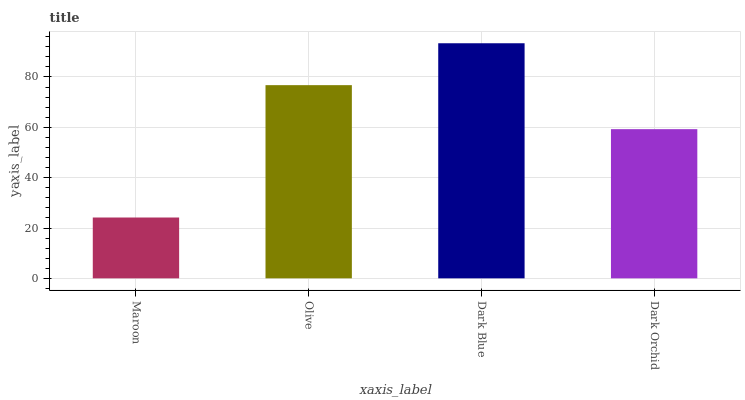Is Maroon the minimum?
Answer yes or no. Yes. Is Dark Blue the maximum?
Answer yes or no. Yes. Is Olive the minimum?
Answer yes or no. No. Is Olive the maximum?
Answer yes or no. No. Is Olive greater than Maroon?
Answer yes or no. Yes. Is Maroon less than Olive?
Answer yes or no. Yes. Is Maroon greater than Olive?
Answer yes or no. No. Is Olive less than Maroon?
Answer yes or no. No. Is Olive the high median?
Answer yes or no. Yes. Is Dark Orchid the low median?
Answer yes or no. Yes. Is Maroon the high median?
Answer yes or no. No. Is Olive the low median?
Answer yes or no. No. 